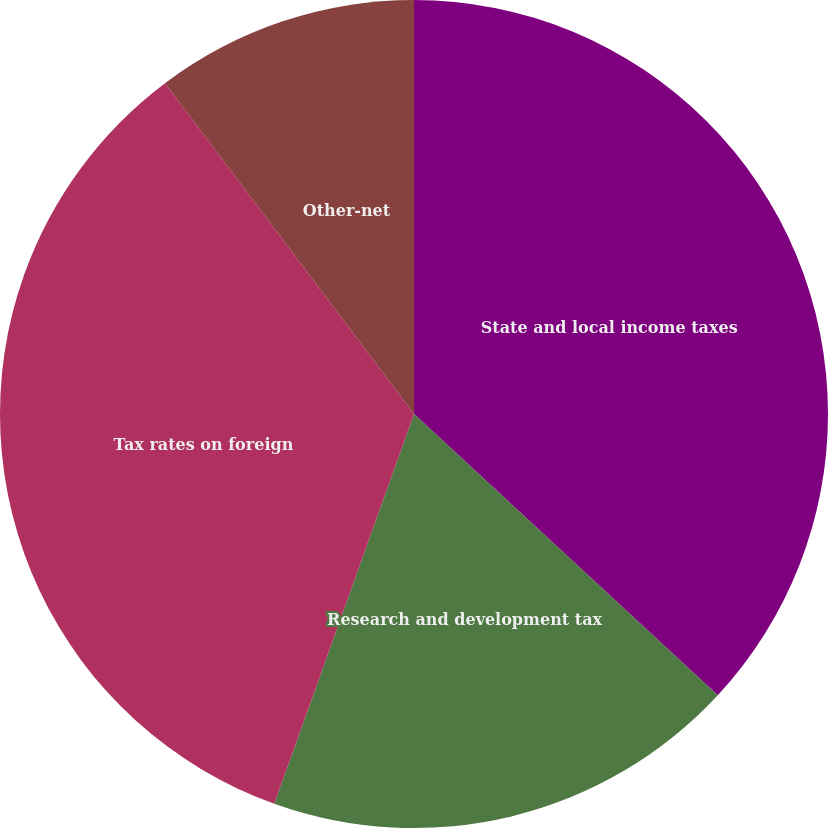<chart> <loc_0><loc_0><loc_500><loc_500><pie_chart><fcel>State and local income taxes<fcel>Research and development tax<fcel>Tax rates on foreign<fcel>Other-net<nl><fcel>36.89%<fcel>18.59%<fcel>34.25%<fcel>10.27%<nl></chart> 